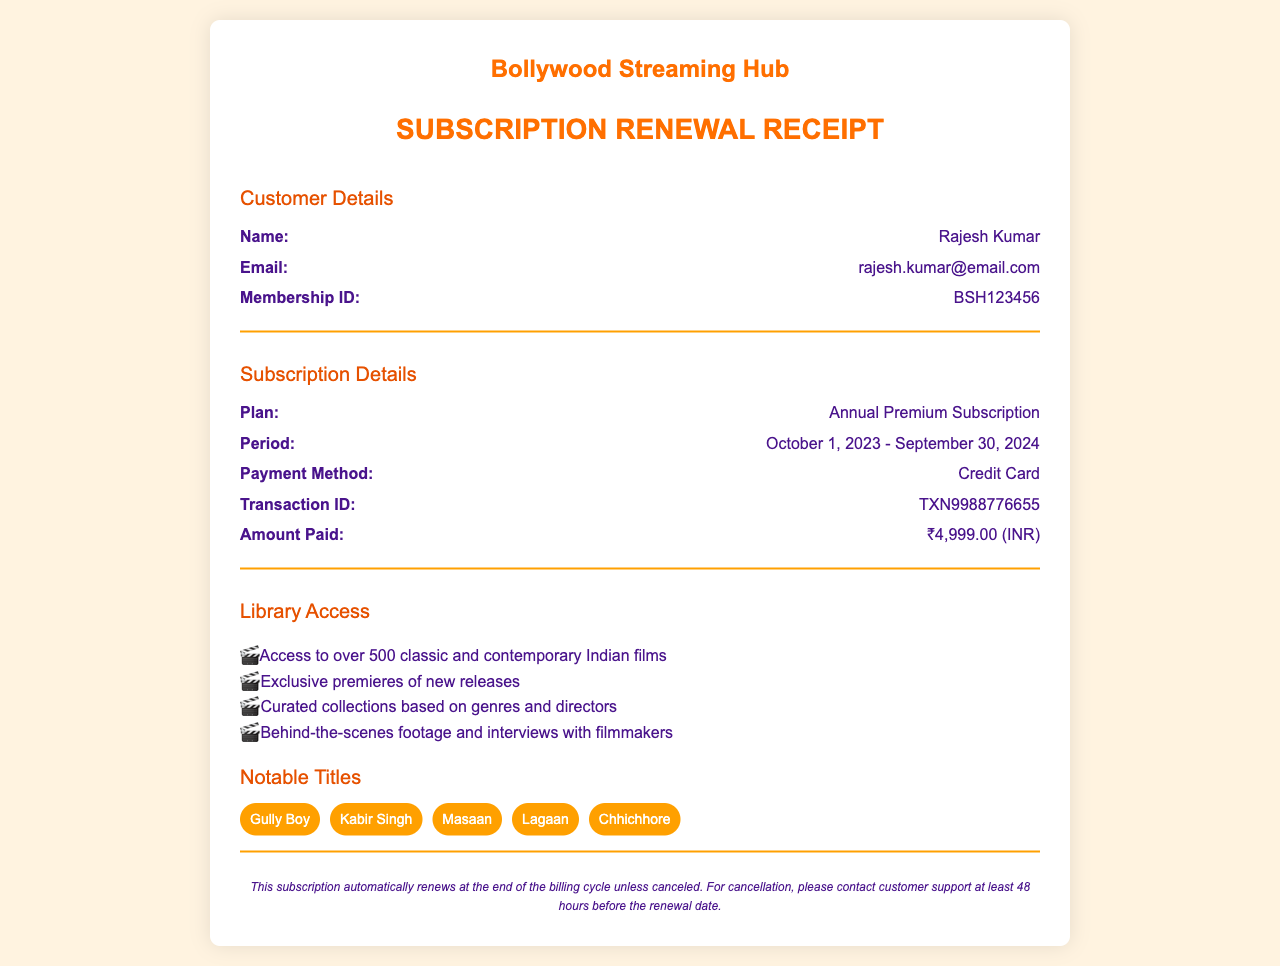What is the customer's name? The customer's name is listed at the top of the Customer Details section.
Answer: Rajesh Kumar What is the email address on the receipt? The email address can be found in the Customer Details section.
Answer: rajesh.kumar@email.com What is the payment amount? The payment amount is stated in the Subscription Details section.
Answer: ₹4,999.00 (INR) What is the membership ID? The membership ID is provided in the Customer Details section.
Answer: BSH123456 What is the duration of the subscription period? The subscription period details are outlined in the Subscription Details section.
Answer: October 1, 2023 - September 30, 2024 What plan has been subscribed to? The plan details are given in the Subscription Details section.
Answer: Annual Premium Subscription What is the method of payment used? The method of payment is mentioned in the Subscription Details section.
Answer: Credit Card What notable title is included in the library? Notable titles are listed in the Library Access section.
Answer: Gully Boy How many classic and contemporary Indian films can be accessed? The number of access films is stated in the Library Access section.
Answer: over 500 What does the receipt note about renewal? The note on renewal is located at the bottom of the document.
Answer: This subscription automatically renews 